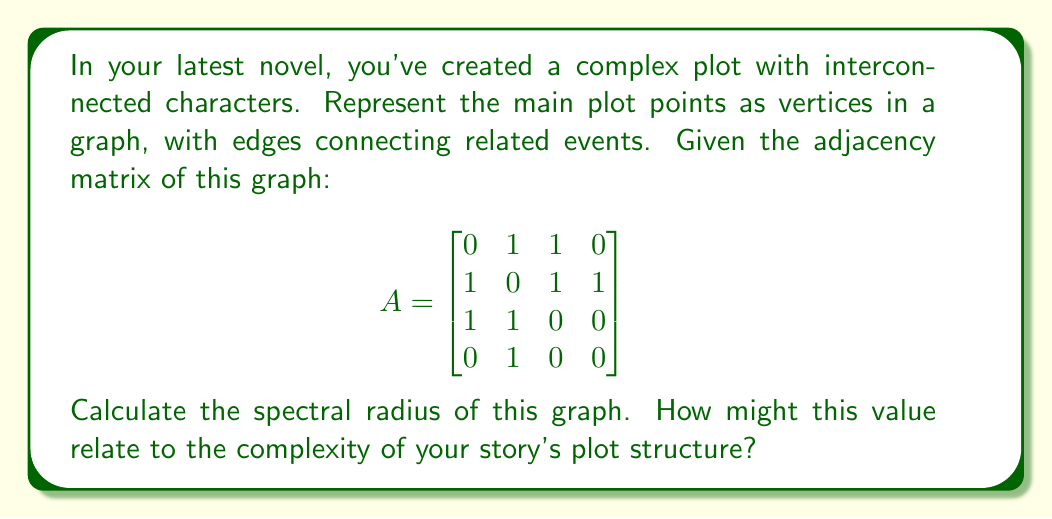Show me your answer to this math problem. To find the spectral radius of the graph, we need to follow these steps:

1) The spectral radius is the largest absolute eigenvalue of the adjacency matrix.

2) To find the eigenvalues, we need to solve the characteristic equation:
   $$det(A - \lambda I) = 0$$

3) Expanding this:
   $$\begin{vmatrix}
   -\lambda & 1 & 1 & 0 \\
   1 & -\lambda & 1 & 1 \\
   1 & 1 & -\lambda & 0 \\
   0 & 1 & 0 & -\lambda
   \end{vmatrix} = 0$$

4) This expands to the characteristic polynomial:
   $$\lambda^4 - \lambda^3 - 3\lambda^2 + \lambda + 1 = 0$$

5) Solving this equation (which can be done numerically), we get the eigenvalues:
   $$\lambda_1 \approx 2.1701, \lambda_2 \approx -1.2470, \lambda_3 \approx 0.5384, \lambda_4 \approx -0.4615$$

6) The spectral radius is the largest absolute value among these, which is $\lambda_1 \approx 2.1701$.

The spectral radius provides insight into the graph's structure. A higher value often indicates a more interconnected plot, with many events influencing each other. This could suggest a complex, interwoven narrative that might be challenging but rewarding for readers to follow, especially considering your physical challenges in writing.
Answer: $2.1701$ 